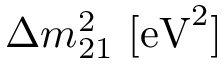<formula> <loc_0><loc_0><loc_500><loc_500>\Delta { m _ { 2 1 } ^ { 2 } } [ { e V } ^ { 2 } ]</formula> 